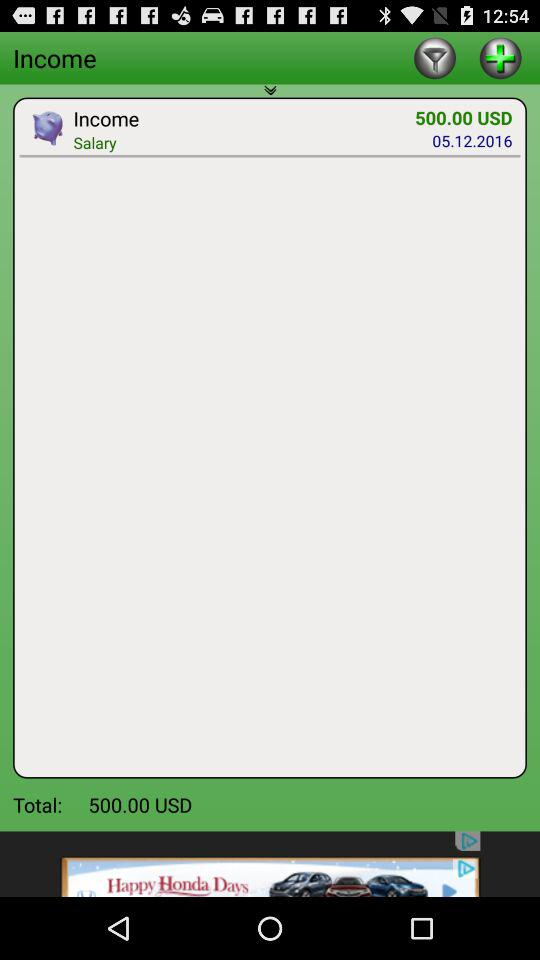What is the date? The date is May 12, 2016. 